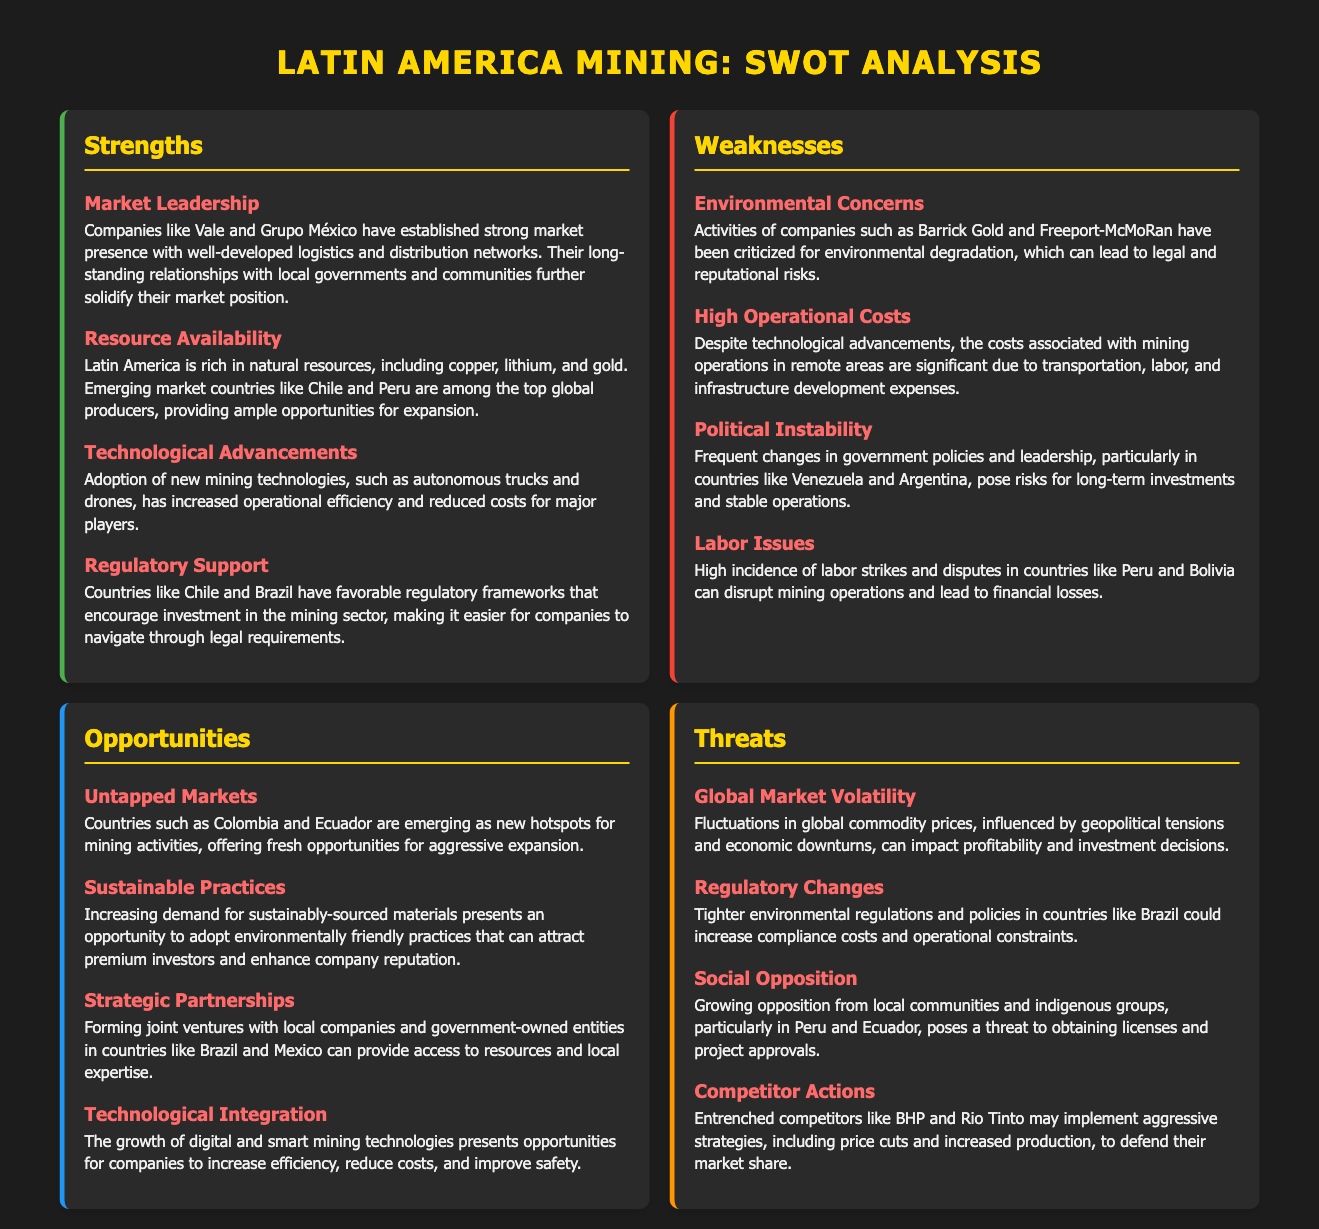What companies have established strong market presence? The document states that Vale and Grupo México have established strong market presence with well-developed logistics and distribution networks.
Answer: Vale and Grupo México Which country is mentioned as a top global producer of copper? The document lists Chile as one of the top global producers of copper, highlighting its resource availability.
Answer: Chile What is a significant weakness related to mining operations in remote areas? The document mentions that high operational costs are a significant weakness in mining operations due to various expenses.
Answer: High Operational Costs Which country is identified as an emerging market for mining activities? Colombia is identified in the document as one of the countries emerging as new hotspots for mining activities.
Answer: Colombia What opportunity relates to environmental practices in mining? The document states that the increasing demand for sustainably-sourced materials presents an opportunity for companies.
Answer: Sustainable Practices What threat is associated with social opposition to mining? The document explains that growing opposition from local communities poses a threat to obtaining licenses and project approvals.
Answer: Social Opposition Which technological advancement is emphasized in the strengths section? The document highlights the adoption of new mining technologies, such as autonomous trucks and drones, as a strength.
Answer: Technological Advancements What do entrenched competitors like BHP and Rio Tinto risk doing? The document notes that these competitors may implement aggressive strategies to defend their market share.
Answer: Competitor Actions What regulatory aspect is considered an opportunity in the document? The document discusses forming joint ventures with local companies, which suggests navigating regulatory conditions is an opportunity.
Answer: Strategic Partnerships 